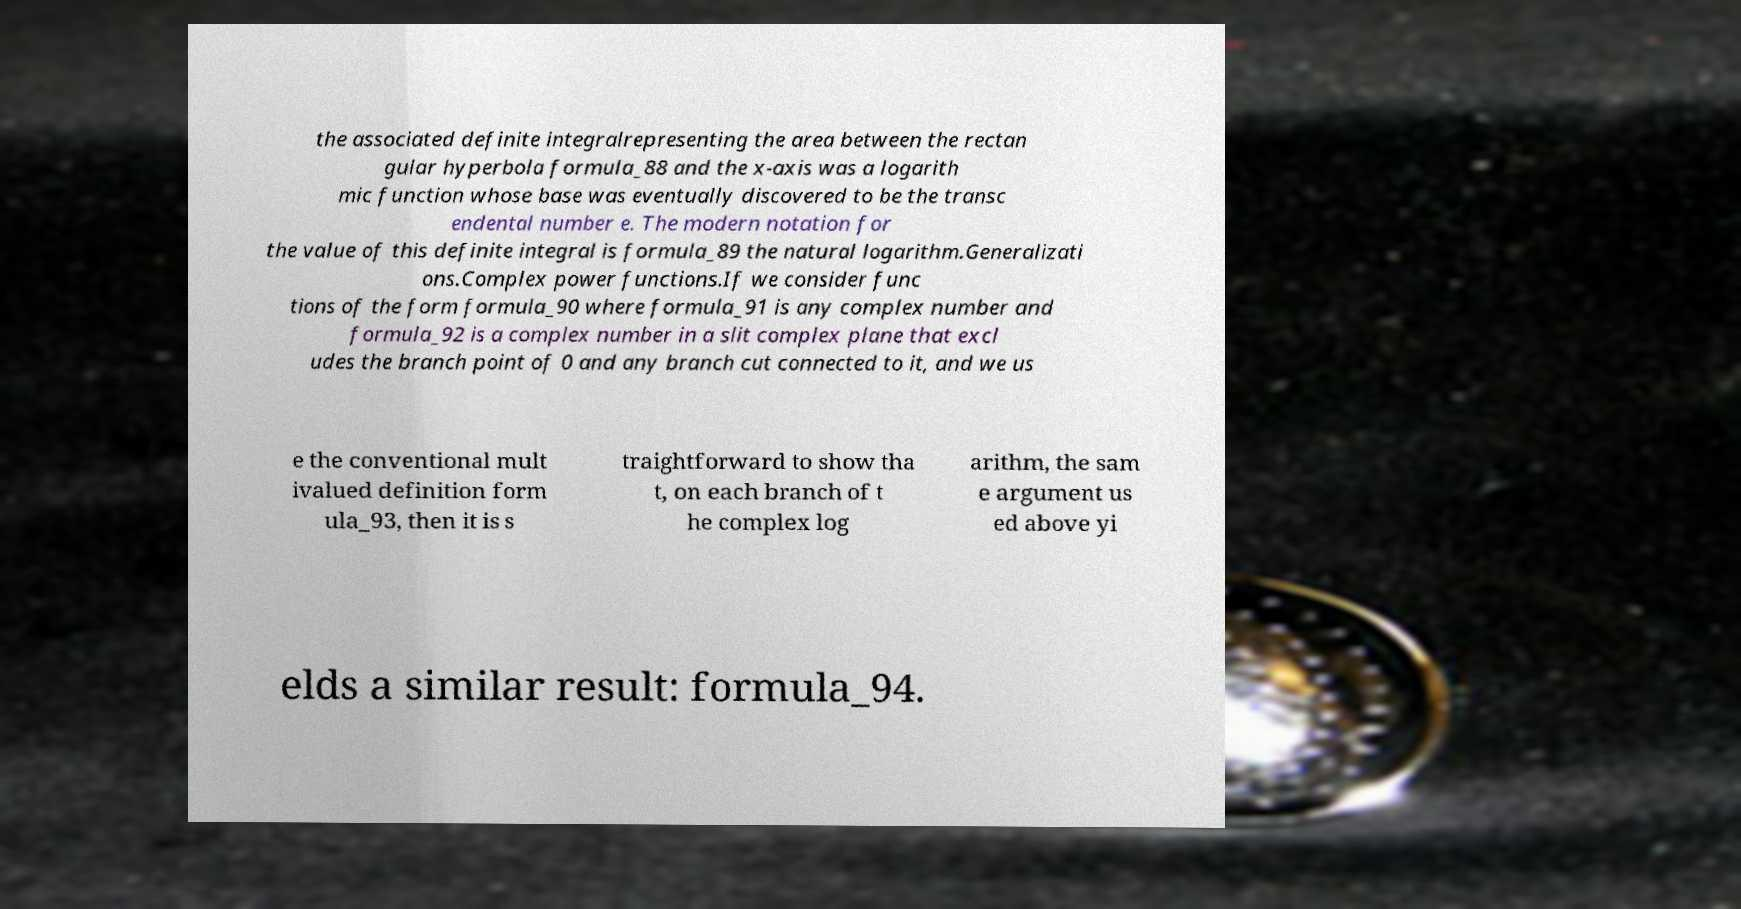Please read and relay the text visible in this image. What does it say? the associated definite integralrepresenting the area between the rectan gular hyperbola formula_88 and the x-axis was a logarith mic function whose base was eventually discovered to be the transc endental number e. The modern notation for the value of this definite integral is formula_89 the natural logarithm.Generalizati ons.Complex power functions.If we consider func tions of the form formula_90 where formula_91 is any complex number and formula_92 is a complex number in a slit complex plane that excl udes the branch point of 0 and any branch cut connected to it, and we us e the conventional mult ivalued definition form ula_93, then it is s traightforward to show tha t, on each branch of t he complex log arithm, the sam e argument us ed above yi elds a similar result: formula_94. 